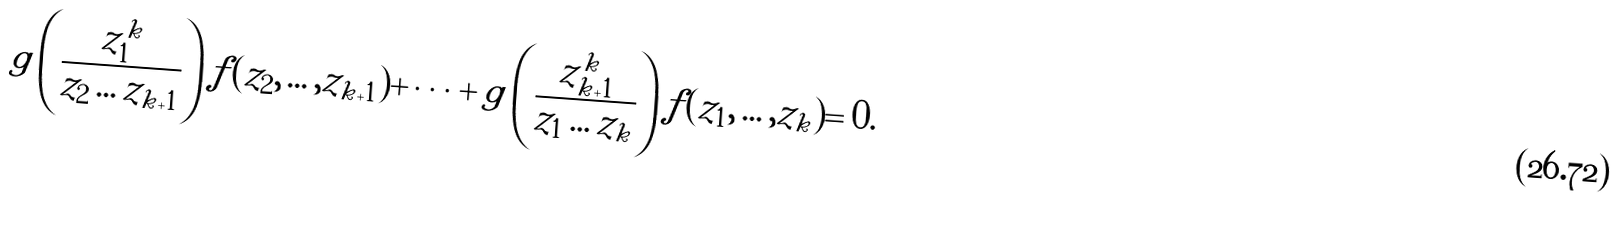<formula> <loc_0><loc_0><loc_500><loc_500>g \left ( \frac { z _ { 1 } ^ { k } } { z _ { 2 } \dots z _ { k + 1 } } \right ) f ( z _ { 2 } , \dots , z _ { k + 1 } ) + \dots + g \left ( \frac { z _ { k + 1 } ^ { k } } { z _ { 1 } \dots z _ { k } } \right ) f ( z _ { 1 } , \dots , z _ { k } ) = 0 .</formula> 